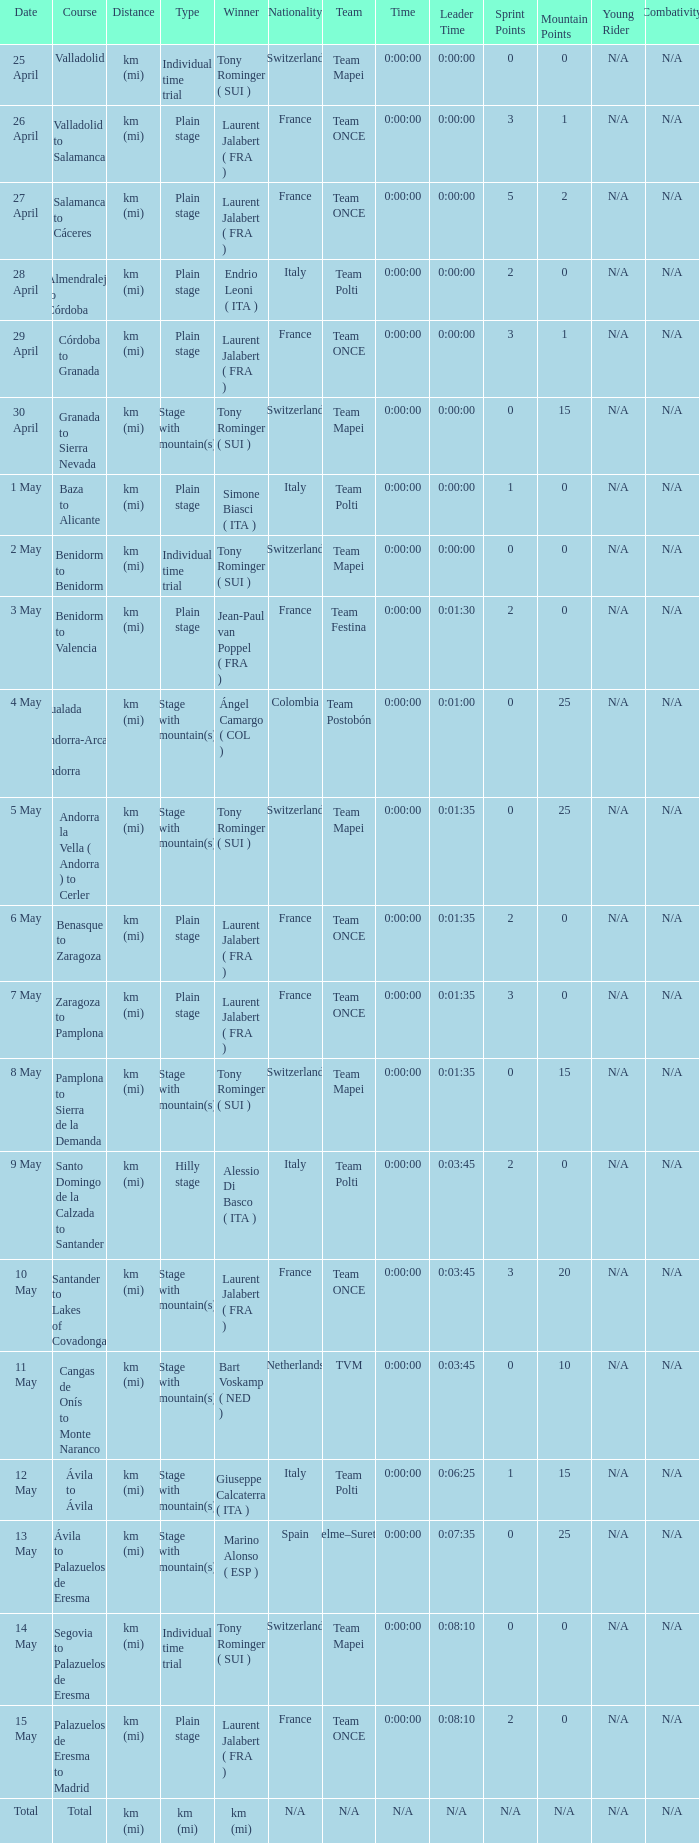What was the date with a winner of km (mi)? Total. 